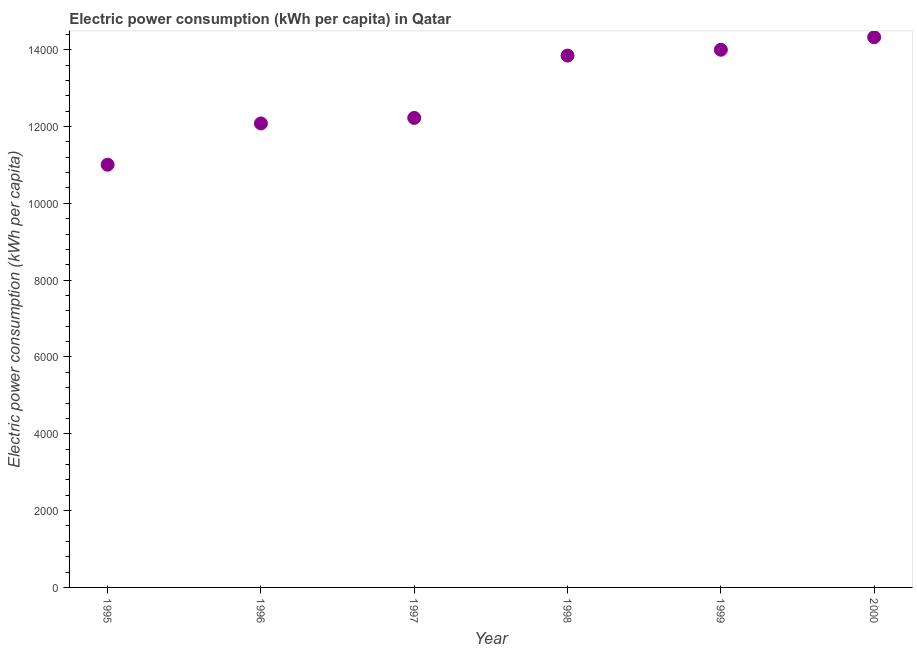What is the electric power consumption in 1998?
Your answer should be compact. 1.38e+04. Across all years, what is the maximum electric power consumption?
Your answer should be compact. 1.43e+04. Across all years, what is the minimum electric power consumption?
Provide a short and direct response. 1.10e+04. In which year was the electric power consumption minimum?
Offer a very short reply. 1995. What is the sum of the electric power consumption?
Make the answer very short. 7.75e+04. What is the difference between the electric power consumption in 1995 and 1999?
Your answer should be compact. -2992.67. What is the average electric power consumption per year?
Provide a succinct answer. 1.29e+04. What is the median electric power consumption?
Offer a very short reply. 1.30e+04. In how many years, is the electric power consumption greater than 13600 kWh per capita?
Provide a succinct answer. 3. Do a majority of the years between 1999 and 1995 (inclusive) have electric power consumption greater than 10800 kWh per capita?
Make the answer very short. Yes. What is the ratio of the electric power consumption in 1998 to that in 1999?
Your response must be concise. 0.99. Is the electric power consumption in 1997 less than that in 1998?
Make the answer very short. Yes. Is the difference between the electric power consumption in 1996 and 1999 greater than the difference between any two years?
Your answer should be compact. No. What is the difference between the highest and the second highest electric power consumption?
Ensure brevity in your answer.  326.39. What is the difference between the highest and the lowest electric power consumption?
Provide a succinct answer. 3319.07. Does the electric power consumption monotonically increase over the years?
Provide a short and direct response. Yes. How many dotlines are there?
Offer a terse response. 1. How many years are there in the graph?
Your answer should be compact. 6. What is the difference between two consecutive major ticks on the Y-axis?
Your answer should be compact. 2000. Does the graph contain any zero values?
Your answer should be very brief. No. Does the graph contain grids?
Your answer should be very brief. No. What is the title of the graph?
Provide a short and direct response. Electric power consumption (kWh per capita) in Qatar. What is the label or title of the Y-axis?
Your answer should be compact. Electric power consumption (kWh per capita). What is the Electric power consumption (kWh per capita) in 1995?
Your answer should be very brief. 1.10e+04. What is the Electric power consumption (kWh per capita) in 1996?
Your response must be concise. 1.21e+04. What is the Electric power consumption (kWh per capita) in 1997?
Make the answer very short. 1.22e+04. What is the Electric power consumption (kWh per capita) in 1998?
Your response must be concise. 1.38e+04. What is the Electric power consumption (kWh per capita) in 1999?
Provide a succinct answer. 1.40e+04. What is the Electric power consumption (kWh per capita) in 2000?
Provide a short and direct response. 1.43e+04. What is the difference between the Electric power consumption (kWh per capita) in 1995 and 1996?
Make the answer very short. -1073.81. What is the difference between the Electric power consumption (kWh per capita) in 1995 and 1997?
Offer a terse response. -1218.66. What is the difference between the Electric power consumption (kWh per capita) in 1995 and 1998?
Offer a very short reply. -2840.13. What is the difference between the Electric power consumption (kWh per capita) in 1995 and 1999?
Make the answer very short. -2992.67. What is the difference between the Electric power consumption (kWh per capita) in 1995 and 2000?
Offer a very short reply. -3319.07. What is the difference between the Electric power consumption (kWh per capita) in 1996 and 1997?
Keep it short and to the point. -144.85. What is the difference between the Electric power consumption (kWh per capita) in 1996 and 1998?
Your response must be concise. -1766.32. What is the difference between the Electric power consumption (kWh per capita) in 1996 and 1999?
Ensure brevity in your answer.  -1918.86. What is the difference between the Electric power consumption (kWh per capita) in 1996 and 2000?
Your response must be concise. -2245.26. What is the difference between the Electric power consumption (kWh per capita) in 1997 and 1998?
Your response must be concise. -1621.46. What is the difference between the Electric power consumption (kWh per capita) in 1997 and 1999?
Offer a very short reply. -1774.01. What is the difference between the Electric power consumption (kWh per capita) in 1997 and 2000?
Offer a terse response. -2100.4. What is the difference between the Electric power consumption (kWh per capita) in 1998 and 1999?
Make the answer very short. -152.54. What is the difference between the Electric power consumption (kWh per capita) in 1998 and 2000?
Ensure brevity in your answer.  -478.94. What is the difference between the Electric power consumption (kWh per capita) in 1999 and 2000?
Your answer should be very brief. -326.39. What is the ratio of the Electric power consumption (kWh per capita) in 1995 to that in 1996?
Your answer should be compact. 0.91. What is the ratio of the Electric power consumption (kWh per capita) in 1995 to that in 1998?
Make the answer very short. 0.8. What is the ratio of the Electric power consumption (kWh per capita) in 1995 to that in 1999?
Provide a succinct answer. 0.79. What is the ratio of the Electric power consumption (kWh per capita) in 1995 to that in 2000?
Your answer should be very brief. 0.77. What is the ratio of the Electric power consumption (kWh per capita) in 1996 to that in 1998?
Your response must be concise. 0.87. What is the ratio of the Electric power consumption (kWh per capita) in 1996 to that in 1999?
Your answer should be very brief. 0.86. What is the ratio of the Electric power consumption (kWh per capita) in 1996 to that in 2000?
Provide a succinct answer. 0.84. What is the ratio of the Electric power consumption (kWh per capita) in 1997 to that in 1998?
Offer a very short reply. 0.88. What is the ratio of the Electric power consumption (kWh per capita) in 1997 to that in 1999?
Ensure brevity in your answer.  0.87. What is the ratio of the Electric power consumption (kWh per capita) in 1997 to that in 2000?
Offer a terse response. 0.85. What is the ratio of the Electric power consumption (kWh per capita) in 1998 to that in 1999?
Ensure brevity in your answer.  0.99. 